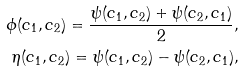Convert formula to latex. <formula><loc_0><loc_0><loc_500><loc_500>\phi ( c _ { 1 } , c _ { 2 } ) = \frac { \psi ( c _ { 1 } , c _ { 2 } ) + \psi ( c _ { 2 } , c _ { 1 } ) } { 2 } , \\ \eta ( c _ { 1 } , c _ { 2 } ) = \psi ( c _ { 1 } , c _ { 2 } ) - \psi ( c _ { 2 } , c _ { 1 } ) ,</formula> 